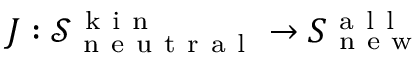<formula> <loc_0><loc_0><loc_500><loc_500>J \colon \mathcal { S } _ { n e u t r a l } ^ { k i n } \to S _ { n e w } ^ { a l l }</formula> 